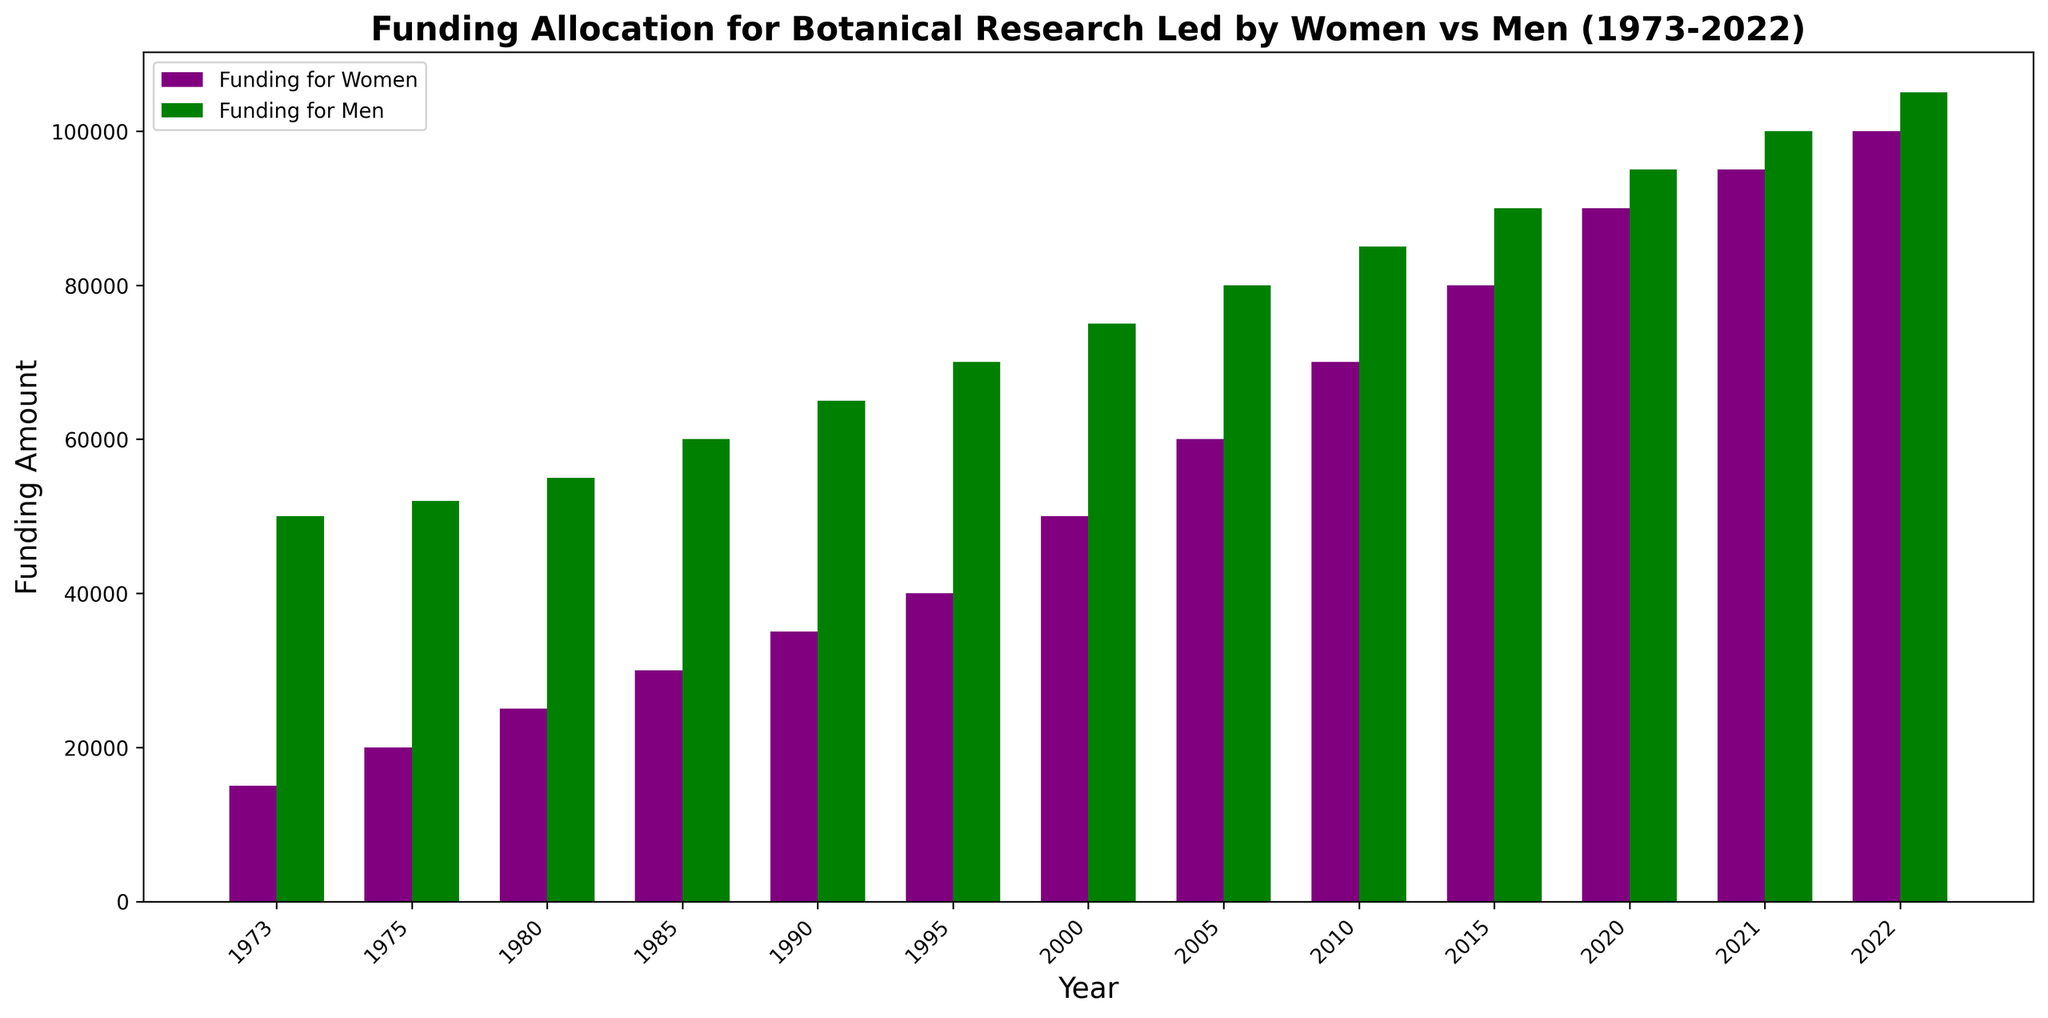Which year had the highest funding for women-led botanical research? Look at the bars labeled for women and identify the tallest bar, which indicates the highest funding amount. It corresponds to the year 2022.
Answer: 2022 How much was the total funding for men-led research in the first five years displayed? Sum the funding amounts for men in the years 1973, 1975, 1980, 1985, and 1990. 50000 + 52000 + 55000 + 60000 + 65000 = 282000
Answer: 282000 What is the trend in funding for women-led research over the 50 years? Observe the heights of the bars for women over the years. They show an upward trend, indicating increasing funding.
Answer: Increasing In which years were the funding gaps between men-led and women-led research at their smallest? Compare the differences between the funding amounts for men and women for each year by visual inspection. The differences are smallest in recent years, particularly in 2021 and 2022.
Answer: 2021, 2022 What is the percentage increase in funding for women-led research from 1973 to 2022? Calculate the funding difference between 2022 and 1973 for women-led research. (100000 - 15000) / 15000 * 100 = 566.67%
Answer: 566.67% During which period did funding for men-led research remain stable? Observe the bars representing men-led research and look for a period where the heights are similar. Between 2005 and 2010, the funding appears stable, but even more so between 2020 to 2022.
Answer: 2020 to 2022 By how much did the funding for women-led research increase from 1980 to 2005? Calculate the difference in funding for women between the years 1980 and 2005. 60000 - 25000 = 35000
Answer: 35000 What are the colors used to represent funding for women and men in the plot? Look at the legend of the plot where the colors are specified. Funding for women is purple and for men is green.
Answer: Purple and Green Which decade saw the most significant increase in funding for women-led botanical research? Compare the decade-by-decade growth in funding for women-led research. The largest jump is from the 2010s to 2020s. Compare 2010 (70000) to 2020 (90000), and 2010 to 2022 (100000).
Answer: 2010s to 2020s What is the average funding amount for men-led research throughout the entire period? Sum all the funding amounts for men and divide by the number of years (13). (50000 + 52000 + 55000 + 60000 + 65000 + 70000 + 75000 + 80000 + 85000 + 90000 + 95000 + 100000 + 105000) / 13 = 73154
Answer: 73154 